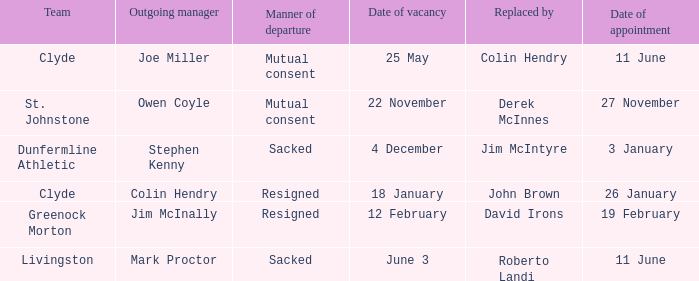Tell me the outgoing manager for 22 november date of vacancy Owen Coyle. 